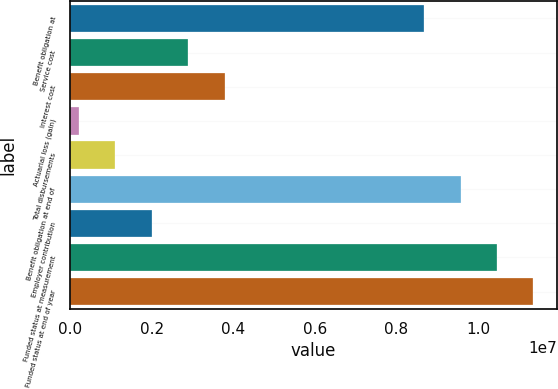Convert chart to OTSL. <chart><loc_0><loc_0><loc_500><loc_500><bar_chart><fcel>Benefit obligation at<fcel>Service cost<fcel>Interest cost<fcel>Actuarial loss (gain)<fcel>Total disbursements<fcel>Benefit obligation at end of<fcel>Employer contribution<fcel>Funded status at measurement<fcel>Funded status at end of year<nl><fcel>8.675e+06<fcel>2.8928e+06<fcel>3.7874e+06<fcel>209000<fcel>1.1036e+06<fcel>9.5696e+06<fcel>1.9982e+06<fcel>1.04642e+07<fcel>1.13588e+07<nl></chart> 